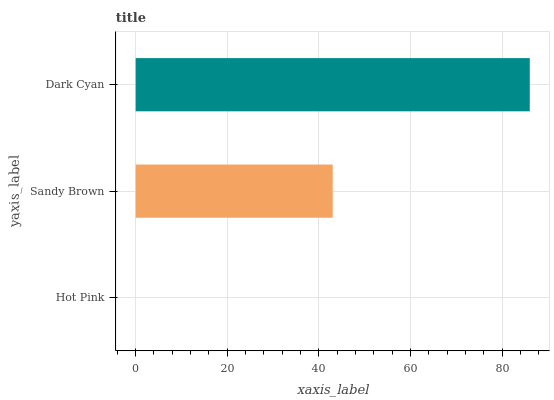Is Hot Pink the minimum?
Answer yes or no. Yes. Is Dark Cyan the maximum?
Answer yes or no. Yes. Is Sandy Brown the minimum?
Answer yes or no. No. Is Sandy Brown the maximum?
Answer yes or no. No. Is Sandy Brown greater than Hot Pink?
Answer yes or no. Yes. Is Hot Pink less than Sandy Brown?
Answer yes or no. Yes. Is Hot Pink greater than Sandy Brown?
Answer yes or no. No. Is Sandy Brown less than Hot Pink?
Answer yes or no. No. Is Sandy Brown the high median?
Answer yes or no. Yes. Is Sandy Brown the low median?
Answer yes or no. Yes. Is Dark Cyan the high median?
Answer yes or no. No. Is Dark Cyan the low median?
Answer yes or no. No. 